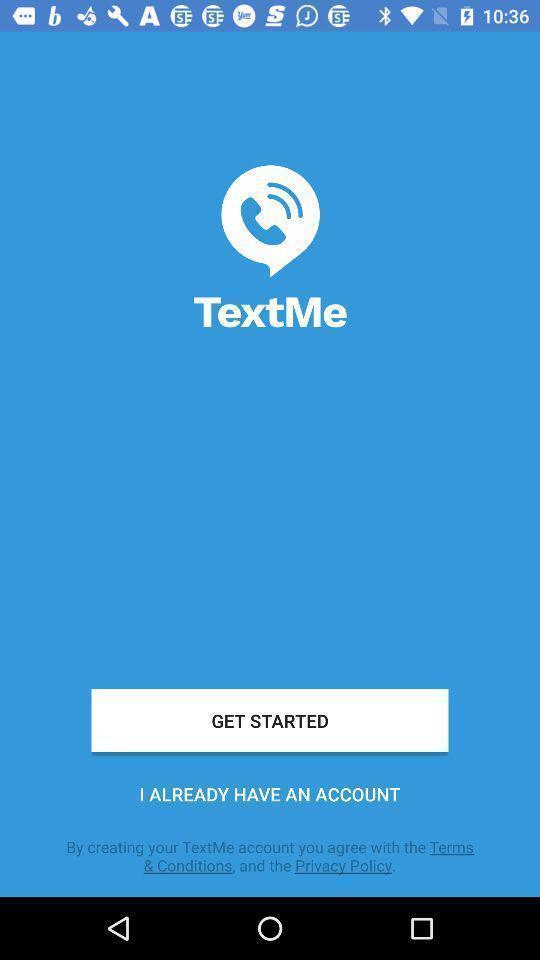Tell me what you see in this picture. Welcome page to continue with account. 